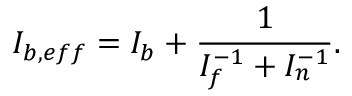Convert formula to latex. <formula><loc_0><loc_0><loc_500><loc_500>I _ { b , e f f } = I _ { b } + \frac { 1 } { I _ { f } ^ { - 1 } + I _ { n } ^ { - 1 } } .</formula> 